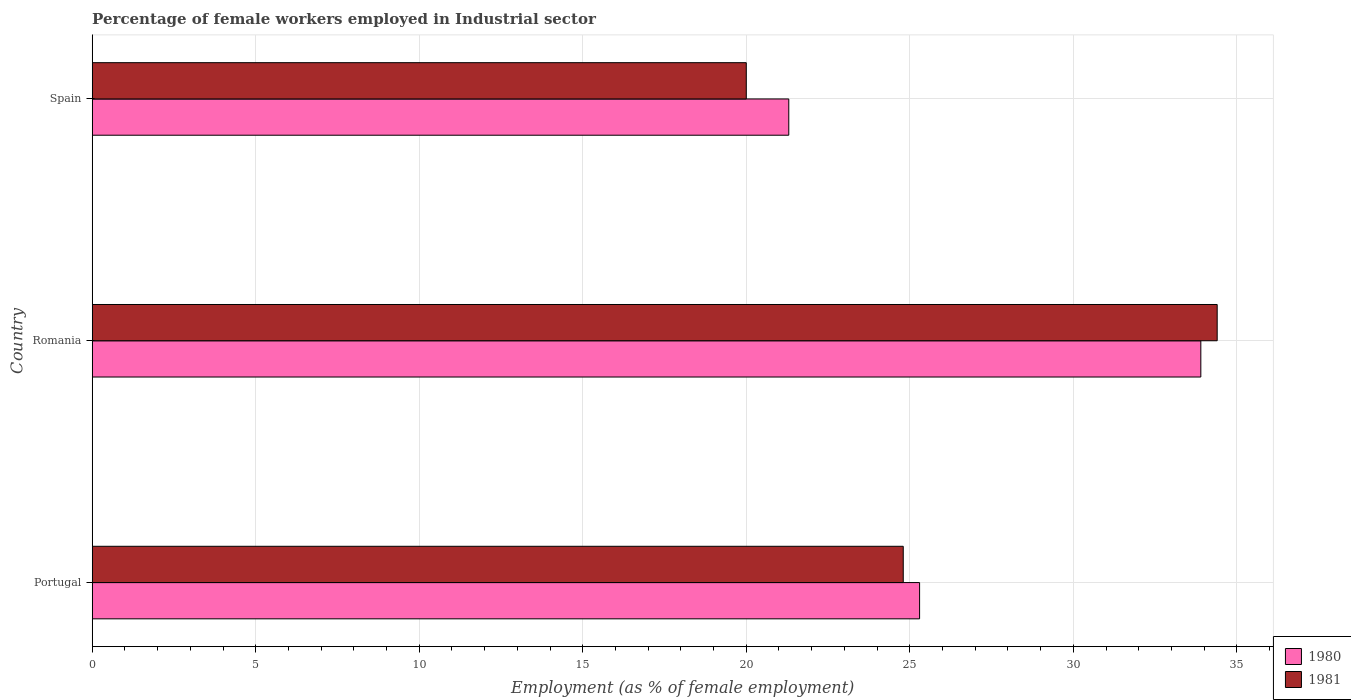How many different coloured bars are there?
Offer a terse response. 2. Are the number of bars per tick equal to the number of legend labels?
Provide a succinct answer. Yes. Are the number of bars on each tick of the Y-axis equal?
Provide a succinct answer. Yes. How many bars are there on the 3rd tick from the top?
Make the answer very short. 2. How many bars are there on the 3rd tick from the bottom?
Your response must be concise. 2. What is the percentage of females employed in Industrial sector in 1981 in Portugal?
Provide a succinct answer. 24.8. Across all countries, what is the maximum percentage of females employed in Industrial sector in 1980?
Provide a succinct answer. 33.9. Across all countries, what is the minimum percentage of females employed in Industrial sector in 1981?
Give a very brief answer. 20. In which country was the percentage of females employed in Industrial sector in 1980 maximum?
Keep it short and to the point. Romania. What is the total percentage of females employed in Industrial sector in 1981 in the graph?
Provide a succinct answer. 79.2. What is the difference between the percentage of females employed in Industrial sector in 1980 in Romania and that in Spain?
Ensure brevity in your answer.  12.6. What is the difference between the percentage of females employed in Industrial sector in 1981 in Spain and the percentage of females employed in Industrial sector in 1980 in Romania?
Provide a succinct answer. -13.9. What is the average percentage of females employed in Industrial sector in 1981 per country?
Keep it short and to the point. 26.4. What is the difference between the percentage of females employed in Industrial sector in 1981 and percentage of females employed in Industrial sector in 1980 in Spain?
Make the answer very short. -1.3. What is the ratio of the percentage of females employed in Industrial sector in 1980 in Portugal to that in Spain?
Offer a terse response. 1.19. Is the percentage of females employed in Industrial sector in 1980 in Romania less than that in Spain?
Your response must be concise. No. Is the difference between the percentage of females employed in Industrial sector in 1981 in Romania and Spain greater than the difference between the percentage of females employed in Industrial sector in 1980 in Romania and Spain?
Your answer should be compact. Yes. What is the difference between the highest and the second highest percentage of females employed in Industrial sector in 1980?
Ensure brevity in your answer.  8.6. What is the difference between the highest and the lowest percentage of females employed in Industrial sector in 1981?
Give a very brief answer. 14.4. What does the 1st bar from the bottom in Spain represents?
Ensure brevity in your answer.  1980. Are all the bars in the graph horizontal?
Your response must be concise. Yes. How many countries are there in the graph?
Your answer should be compact. 3. Are the values on the major ticks of X-axis written in scientific E-notation?
Provide a short and direct response. No. Does the graph contain any zero values?
Provide a short and direct response. No. Where does the legend appear in the graph?
Make the answer very short. Bottom right. How many legend labels are there?
Your answer should be very brief. 2. How are the legend labels stacked?
Your response must be concise. Vertical. What is the title of the graph?
Make the answer very short. Percentage of female workers employed in Industrial sector. What is the label or title of the X-axis?
Ensure brevity in your answer.  Employment (as % of female employment). What is the Employment (as % of female employment) in 1980 in Portugal?
Your response must be concise. 25.3. What is the Employment (as % of female employment) of 1981 in Portugal?
Your answer should be compact. 24.8. What is the Employment (as % of female employment) in 1980 in Romania?
Offer a terse response. 33.9. What is the Employment (as % of female employment) in 1981 in Romania?
Provide a short and direct response. 34.4. What is the Employment (as % of female employment) in 1980 in Spain?
Offer a very short reply. 21.3. What is the Employment (as % of female employment) in 1981 in Spain?
Provide a short and direct response. 20. Across all countries, what is the maximum Employment (as % of female employment) in 1980?
Offer a terse response. 33.9. Across all countries, what is the maximum Employment (as % of female employment) in 1981?
Offer a very short reply. 34.4. Across all countries, what is the minimum Employment (as % of female employment) in 1980?
Provide a succinct answer. 21.3. Across all countries, what is the minimum Employment (as % of female employment) in 1981?
Provide a short and direct response. 20. What is the total Employment (as % of female employment) in 1980 in the graph?
Your answer should be compact. 80.5. What is the total Employment (as % of female employment) of 1981 in the graph?
Ensure brevity in your answer.  79.2. What is the difference between the Employment (as % of female employment) in 1980 in Portugal and that in Romania?
Your answer should be compact. -8.6. What is the difference between the Employment (as % of female employment) in 1981 in Portugal and that in Spain?
Provide a short and direct response. 4.8. What is the difference between the Employment (as % of female employment) in 1980 in Portugal and the Employment (as % of female employment) in 1981 in Romania?
Make the answer very short. -9.1. What is the difference between the Employment (as % of female employment) in 1980 in Portugal and the Employment (as % of female employment) in 1981 in Spain?
Ensure brevity in your answer.  5.3. What is the average Employment (as % of female employment) in 1980 per country?
Your answer should be compact. 26.83. What is the average Employment (as % of female employment) in 1981 per country?
Your answer should be compact. 26.4. What is the difference between the Employment (as % of female employment) of 1980 and Employment (as % of female employment) of 1981 in Spain?
Keep it short and to the point. 1.3. What is the ratio of the Employment (as % of female employment) of 1980 in Portugal to that in Romania?
Offer a terse response. 0.75. What is the ratio of the Employment (as % of female employment) in 1981 in Portugal to that in Romania?
Offer a terse response. 0.72. What is the ratio of the Employment (as % of female employment) in 1980 in Portugal to that in Spain?
Offer a terse response. 1.19. What is the ratio of the Employment (as % of female employment) in 1981 in Portugal to that in Spain?
Offer a very short reply. 1.24. What is the ratio of the Employment (as % of female employment) in 1980 in Romania to that in Spain?
Make the answer very short. 1.59. What is the ratio of the Employment (as % of female employment) of 1981 in Romania to that in Spain?
Ensure brevity in your answer.  1.72. What is the difference between the highest and the lowest Employment (as % of female employment) in 1981?
Your response must be concise. 14.4. 